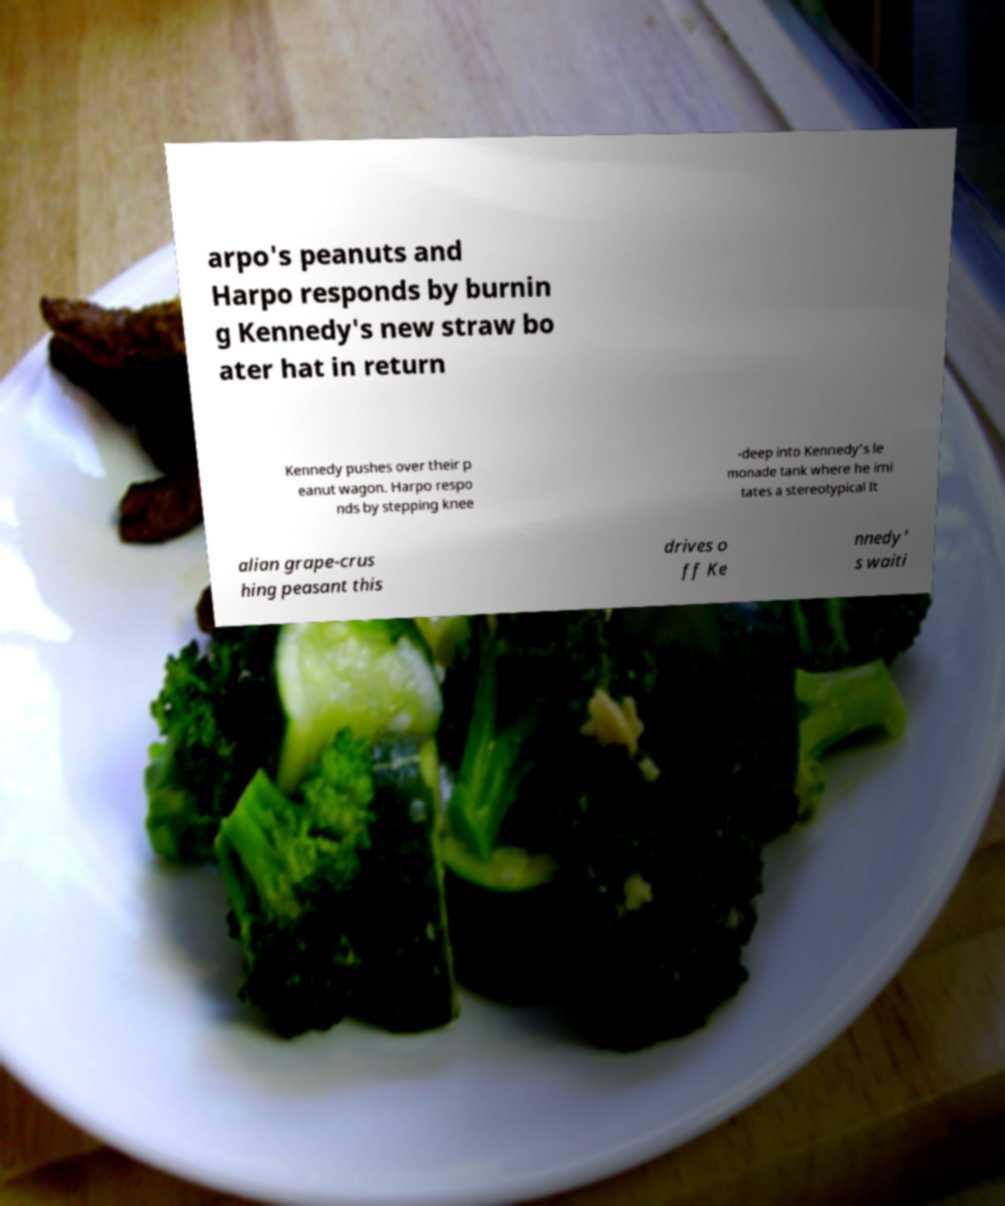Could you assist in decoding the text presented in this image and type it out clearly? arpo's peanuts and Harpo responds by burnin g Kennedy's new straw bo ater hat in return Kennedy pushes over their p eanut wagon. Harpo respo nds by stepping knee -deep into Kennedy's le monade tank where he imi tates a stereotypical It alian grape-crus hing peasant this drives o ff Ke nnedy' s waiti 